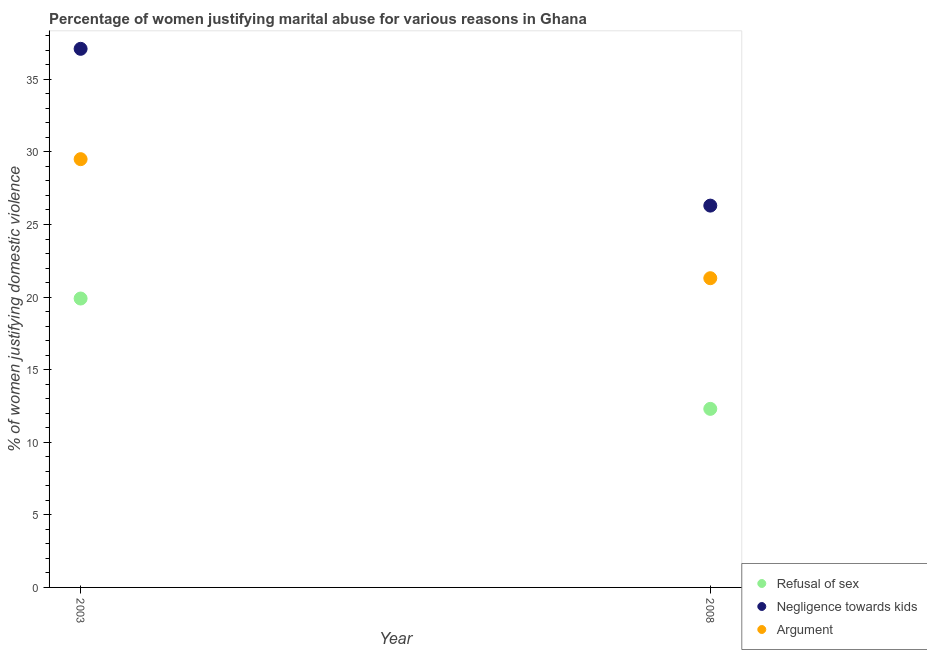How many different coloured dotlines are there?
Offer a very short reply. 3. Is the number of dotlines equal to the number of legend labels?
Provide a succinct answer. Yes. What is the percentage of women justifying domestic violence due to refusal of sex in 2008?
Give a very brief answer. 12.3. Across all years, what is the maximum percentage of women justifying domestic violence due to arguments?
Offer a terse response. 29.5. Across all years, what is the minimum percentage of women justifying domestic violence due to negligence towards kids?
Provide a succinct answer. 26.3. In which year was the percentage of women justifying domestic violence due to refusal of sex minimum?
Offer a very short reply. 2008. What is the total percentage of women justifying domestic violence due to refusal of sex in the graph?
Offer a terse response. 32.2. What is the difference between the percentage of women justifying domestic violence due to negligence towards kids in 2003 and that in 2008?
Keep it short and to the point. 10.8. What is the difference between the percentage of women justifying domestic violence due to arguments in 2003 and the percentage of women justifying domestic violence due to negligence towards kids in 2008?
Give a very brief answer. 3.2. What is the average percentage of women justifying domestic violence due to negligence towards kids per year?
Your answer should be compact. 31.7. In the year 2008, what is the difference between the percentage of women justifying domestic violence due to refusal of sex and percentage of women justifying domestic violence due to negligence towards kids?
Make the answer very short. -14. What is the ratio of the percentage of women justifying domestic violence due to refusal of sex in 2003 to that in 2008?
Your answer should be very brief. 1.62. In how many years, is the percentage of women justifying domestic violence due to negligence towards kids greater than the average percentage of women justifying domestic violence due to negligence towards kids taken over all years?
Ensure brevity in your answer.  1. Is the percentage of women justifying domestic violence due to refusal of sex strictly greater than the percentage of women justifying domestic violence due to negligence towards kids over the years?
Provide a succinct answer. No. Is the percentage of women justifying domestic violence due to refusal of sex strictly less than the percentage of women justifying domestic violence due to negligence towards kids over the years?
Your response must be concise. Yes. How many dotlines are there?
Make the answer very short. 3. How many years are there in the graph?
Offer a very short reply. 2. Does the graph contain grids?
Offer a very short reply. No. How are the legend labels stacked?
Ensure brevity in your answer.  Vertical. What is the title of the graph?
Provide a short and direct response. Percentage of women justifying marital abuse for various reasons in Ghana. Does "Taxes" appear as one of the legend labels in the graph?
Provide a succinct answer. No. What is the label or title of the Y-axis?
Give a very brief answer. % of women justifying domestic violence. What is the % of women justifying domestic violence of Negligence towards kids in 2003?
Your response must be concise. 37.1. What is the % of women justifying domestic violence in Argument in 2003?
Your answer should be very brief. 29.5. What is the % of women justifying domestic violence in Refusal of sex in 2008?
Provide a short and direct response. 12.3. What is the % of women justifying domestic violence of Negligence towards kids in 2008?
Your answer should be compact. 26.3. What is the % of women justifying domestic violence in Argument in 2008?
Offer a very short reply. 21.3. Across all years, what is the maximum % of women justifying domestic violence in Refusal of sex?
Give a very brief answer. 19.9. Across all years, what is the maximum % of women justifying domestic violence of Negligence towards kids?
Your answer should be compact. 37.1. Across all years, what is the maximum % of women justifying domestic violence in Argument?
Offer a terse response. 29.5. Across all years, what is the minimum % of women justifying domestic violence of Refusal of sex?
Your answer should be very brief. 12.3. Across all years, what is the minimum % of women justifying domestic violence of Negligence towards kids?
Provide a short and direct response. 26.3. Across all years, what is the minimum % of women justifying domestic violence in Argument?
Your answer should be very brief. 21.3. What is the total % of women justifying domestic violence in Refusal of sex in the graph?
Your response must be concise. 32.2. What is the total % of women justifying domestic violence of Negligence towards kids in the graph?
Your response must be concise. 63.4. What is the total % of women justifying domestic violence in Argument in the graph?
Offer a terse response. 50.8. What is the difference between the % of women justifying domestic violence of Refusal of sex in 2003 and that in 2008?
Your answer should be very brief. 7.6. What is the difference between the % of women justifying domestic violence of Refusal of sex in 2003 and the % of women justifying domestic violence of Negligence towards kids in 2008?
Offer a terse response. -6.4. What is the difference between the % of women justifying domestic violence in Refusal of sex in 2003 and the % of women justifying domestic violence in Argument in 2008?
Keep it short and to the point. -1.4. What is the difference between the % of women justifying domestic violence in Negligence towards kids in 2003 and the % of women justifying domestic violence in Argument in 2008?
Your answer should be very brief. 15.8. What is the average % of women justifying domestic violence in Refusal of sex per year?
Give a very brief answer. 16.1. What is the average % of women justifying domestic violence of Negligence towards kids per year?
Give a very brief answer. 31.7. What is the average % of women justifying domestic violence in Argument per year?
Your answer should be compact. 25.4. In the year 2003, what is the difference between the % of women justifying domestic violence of Refusal of sex and % of women justifying domestic violence of Negligence towards kids?
Offer a terse response. -17.2. In the year 2003, what is the difference between the % of women justifying domestic violence of Refusal of sex and % of women justifying domestic violence of Argument?
Offer a terse response. -9.6. What is the ratio of the % of women justifying domestic violence of Refusal of sex in 2003 to that in 2008?
Provide a succinct answer. 1.62. What is the ratio of the % of women justifying domestic violence of Negligence towards kids in 2003 to that in 2008?
Your answer should be compact. 1.41. What is the ratio of the % of women justifying domestic violence in Argument in 2003 to that in 2008?
Make the answer very short. 1.39. What is the difference between the highest and the second highest % of women justifying domestic violence of Refusal of sex?
Offer a very short reply. 7.6. What is the difference between the highest and the lowest % of women justifying domestic violence in Refusal of sex?
Ensure brevity in your answer.  7.6. 